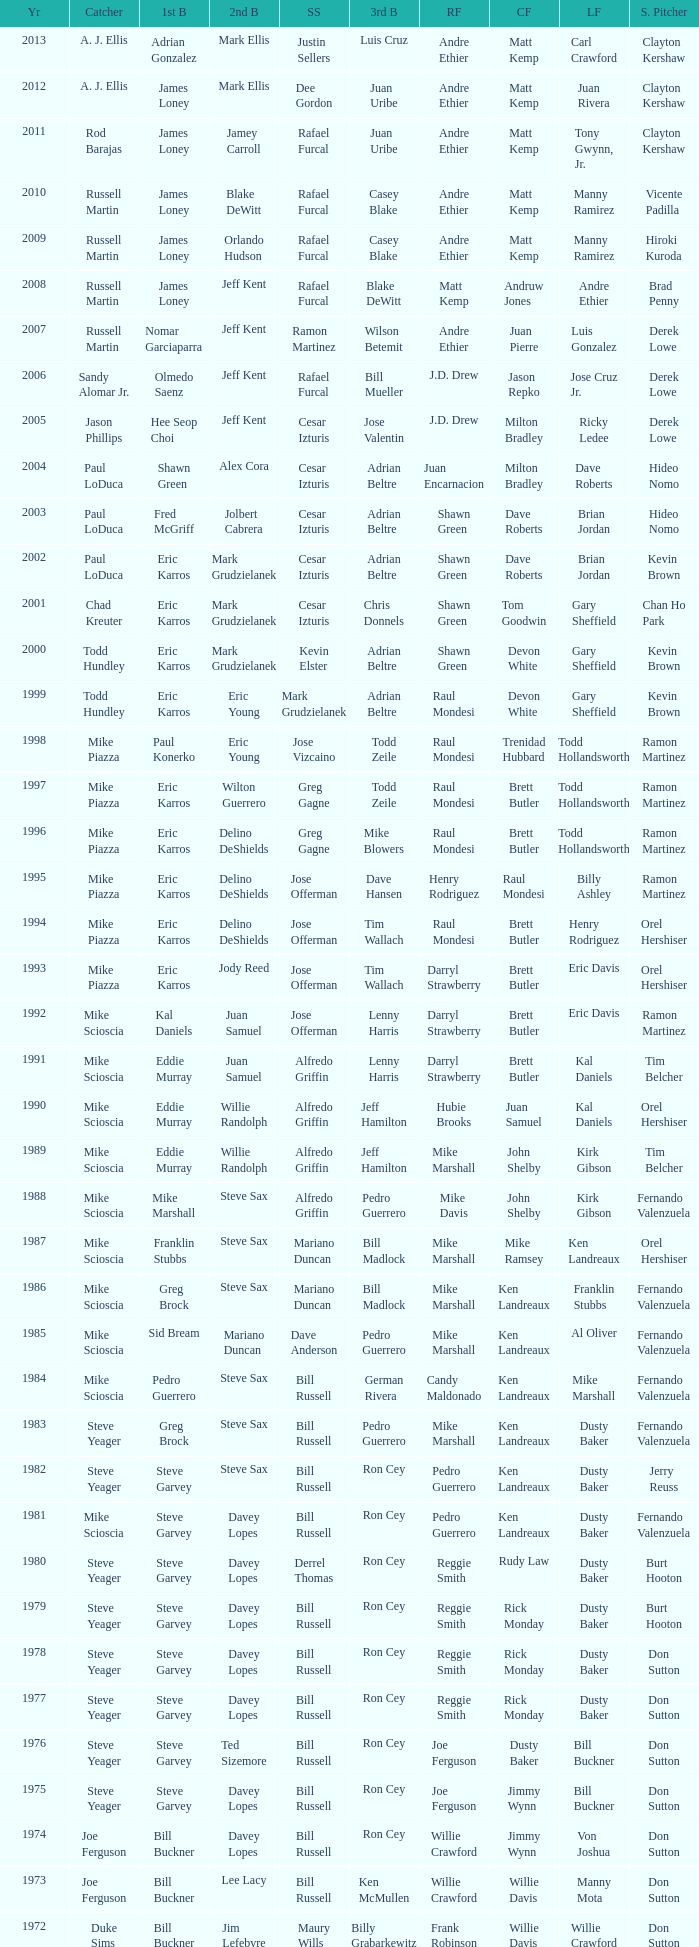Who was the RF when the SP was vicente padilla? Andre Ethier. 